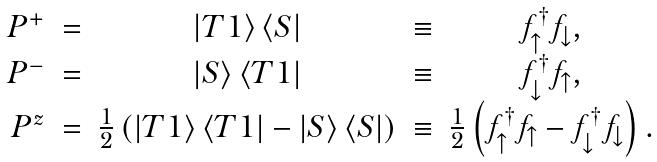Convert formula to latex. <formula><loc_0><loc_0><loc_500><loc_500>\begin{array} { r c c c c } P ^ { + } & = & \left | T 1 \right \rangle \left \langle S \right | & \equiv & f ^ { \dagger } _ { \uparrow } f _ { \downarrow } , \\ P ^ { - } & = & \left | S \right \rangle \left \langle T 1 \right | & \equiv & f ^ { \dagger } _ { \downarrow } f _ { \uparrow } , \\ P ^ { z } & = & \frac { 1 } { 2 } \left ( \left | T 1 \right \rangle \left \langle T 1 \right | - \left | S \right \rangle \left \langle S \right | \right ) & \equiv & \frac { 1 } { 2 } \left ( f ^ { \dagger } _ { \uparrow } f _ { \uparrow } - f ^ { \dagger } _ { \downarrow } f _ { \downarrow } \right ) . \end{array}</formula> 